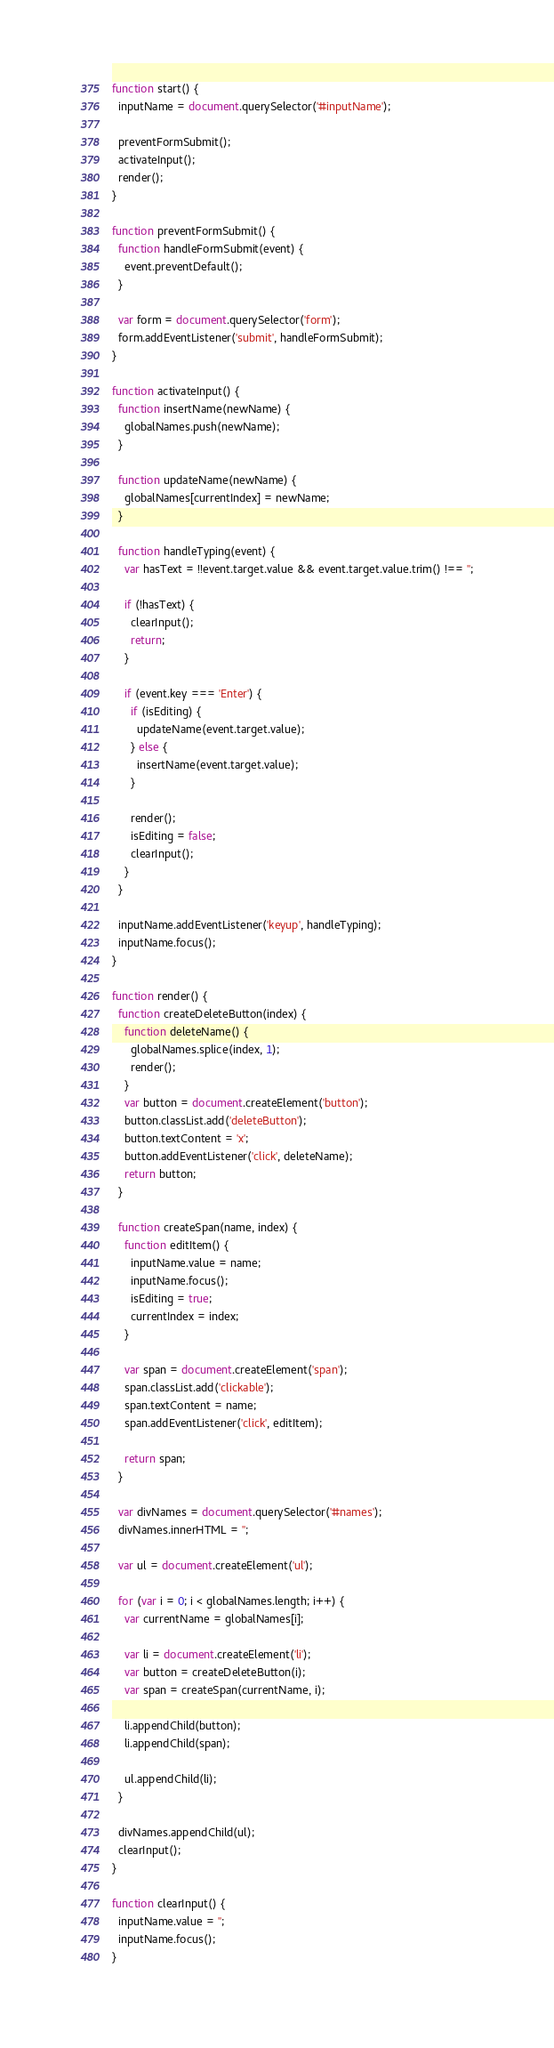<code> <loc_0><loc_0><loc_500><loc_500><_JavaScript_>
function start() {
  inputName = document.querySelector('#inputName');

  preventFormSubmit();
  activateInput();
  render();
}

function preventFormSubmit() {
  function handleFormSubmit(event) {
    event.preventDefault();
  }

  var form = document.querySelector('form');
  form.addEventListener('submit', handleFormSubmit);
}

function activateInput() {
  function insertName(newName) {
    globalNames.push(newName);
  }

  function updateName(newName) {
    globalNames[currentIndex] = newName;
  }

  function handleTyping(event) {
    var hasText = !!event.target.value && event.target.value.trim() !== '';

    if (!hasText) {
      clearInput();
      return;
    }

    if (event.key === 'Enter') {
      if (isEditing) {
        updateName(event.target.value);
      } else {
        insertName(event.target.value);
      }

      render();
      isEditing = false;
      clearInput();
    }
  }

  inputName.addEventListener('keyup', handleTyping);
  inputName.focus();
}

function render() {
  function createDeleteButton(index) {
    function deleteName() {
      globalNames.splice(index, 1);
      render();
    }
    var button = document.createElement('button');
    button.classList.add('deleteButton');
    button.textContent = 'x';
    button.addEventListener('click', deleteName);
    return button;
  }

  function createSpan(name, index) {
    function editItem() {
      inputName.value = name;
      inputName.focus();
      isEditing = true;
      currentIndex = index;
    }

    var span = document.createElement('span');
    span.classList.add('clickable');
    span.textContent = name;
    span.addEventListener('click', editItem);

    return span;
  }

  var divNames = document.querySelector('#names');
  divNames.innerHTML = '';

  var ul = document.createElement('ul');

  for (var i = 0; i < globalNames.length; i++) {
    var currentName = globalNames[i];

    var li = document.createElement('li');
    var button = createDeleteButton(i);
    var span = createSpan(currentName, i);

    li.appendChild(button);
    li.appendChild(span);

    ul.appendChild(li);
  }

  divNames.appendChild(ul);
  clearInput();
}

function clearInput() {
  inputName.value = '';
  inputName.focus();
}
</code> 